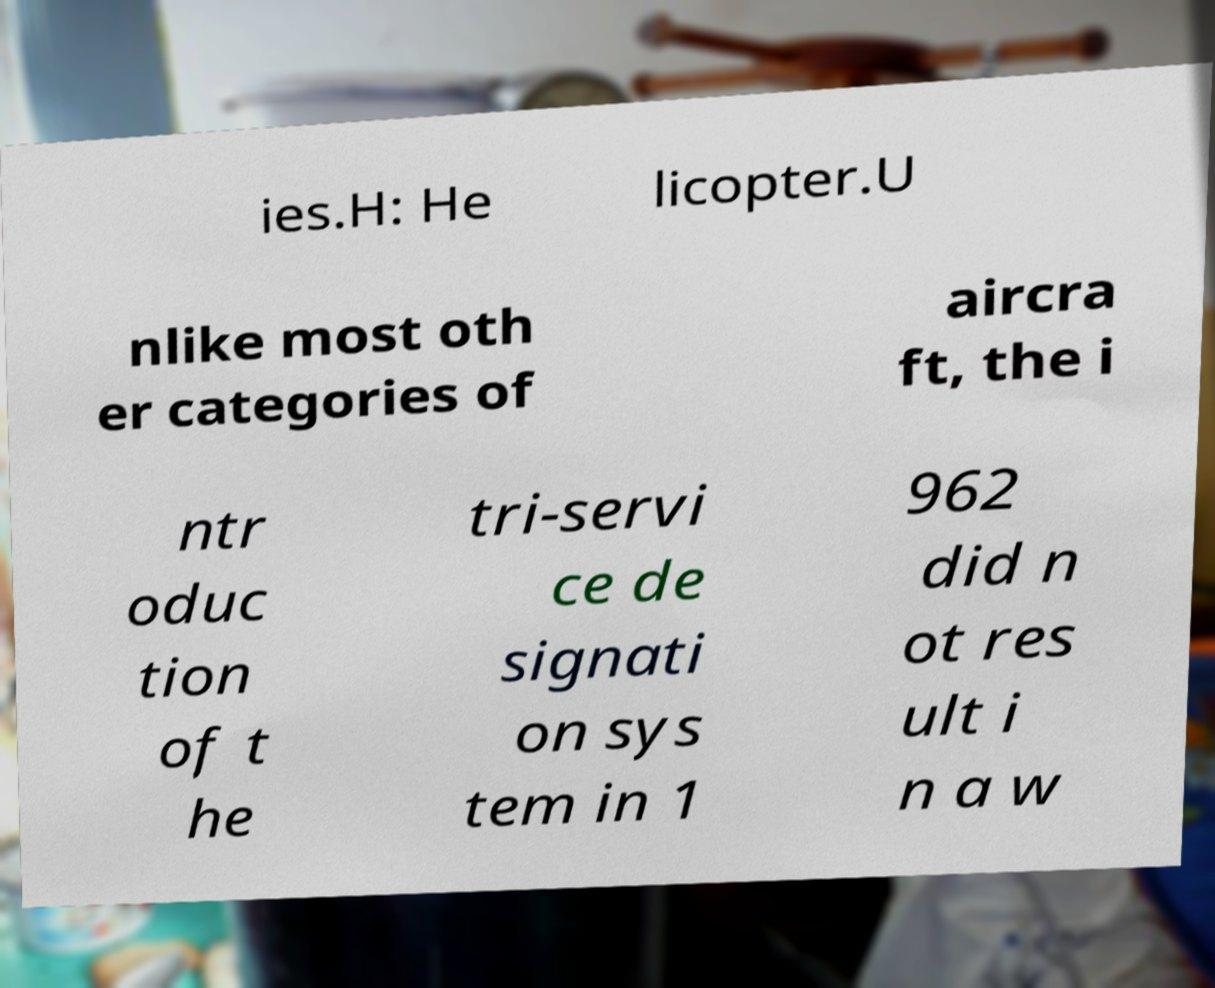What messages or text are displayed in this image? I need them in a readable, typed format. ies.H: He licopter.U nlike most oth er categories of aircra ft, the i ntr oduc tion of t he tri-servi ce de signati on sys tem in 1 962 did n ot res ult i n a w 